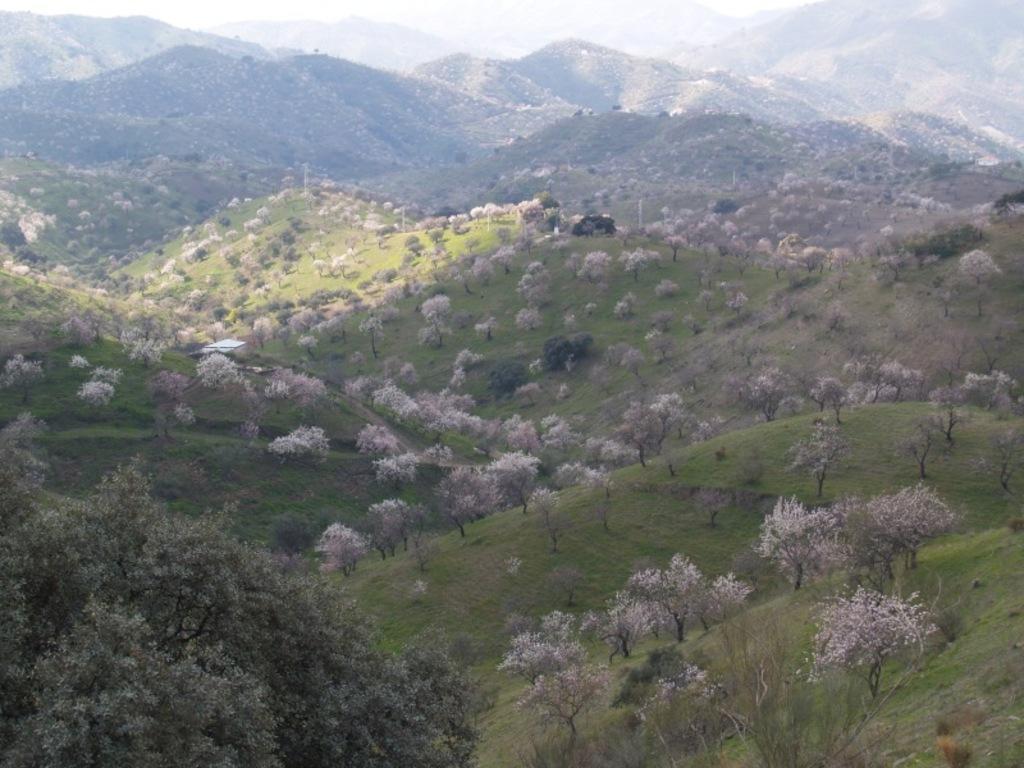Describe this image in one or two sentences. This is an outside view. In this image I can see many hills and trees on the ground. 